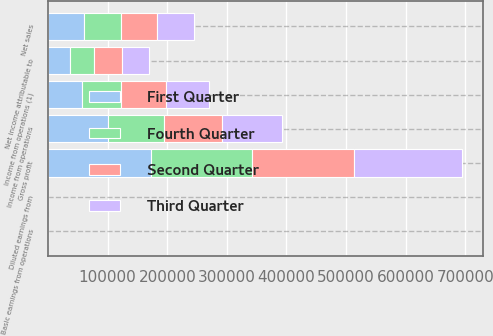Convert chart. <chart><loc_0><loc_0><loc_500><loc_500><stacked_bar_chart><ecel><fcel>Net sales<fcel>Gross profit<fcel>Income from operations<fcel>Net income attributable to<fcel>Basic earnings from operations<fcel>Diluted earnings from<fcel>Income from operations (1)<nl><fcel>Fourth Quarter<fcel>61127.5<fcel>169381<fcel>94110<fcel>40952<fcel>1.24<fcel>1.22<fcel>66377<nl><fcel>First Quarter<fcel>61127.5<fcel>173427<fcel>100865<fcel>36334<fcel>1.35<fcel>1.33<fcel>56362<nl><fcel>Second Quarter<fcel>61127.5<fcel>171279<fcel>96842<fcel>46600<fcel>1.32<fcel>1.3<fcel>75453<nl><fcel>Third Quarter<fcel>61127.5<fcel>180480<fcel>100462<fcel>46263<fcel>1.35<fcel>1.34<fcel>72509<nl></chart> 